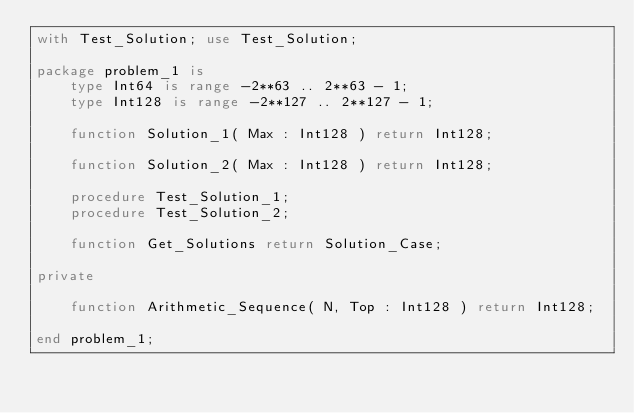Convert code to text. <code><loc_0><loc_0><loc_500><loc_500><_Ada_>with Test_Solution; use Test_Solution;

package problem_1 is
    type Int64 is range -2**63 .. 2**63 - 1;
    type Int128 is range -2**127 .. 2**127 - 1;

    function Solution_1( Max : Int128 ) return Int128;

    function Solution_2( Max : Int128 ) return Int128;

    procedure Test_Solution_1;
    procedure Test_Solution_2;

    function Get_Solutions return Solution_Case;

private

    function Arithmetic_Sequence( N, Top : Int128 ) return Int128;

end problem_1;
</code> 